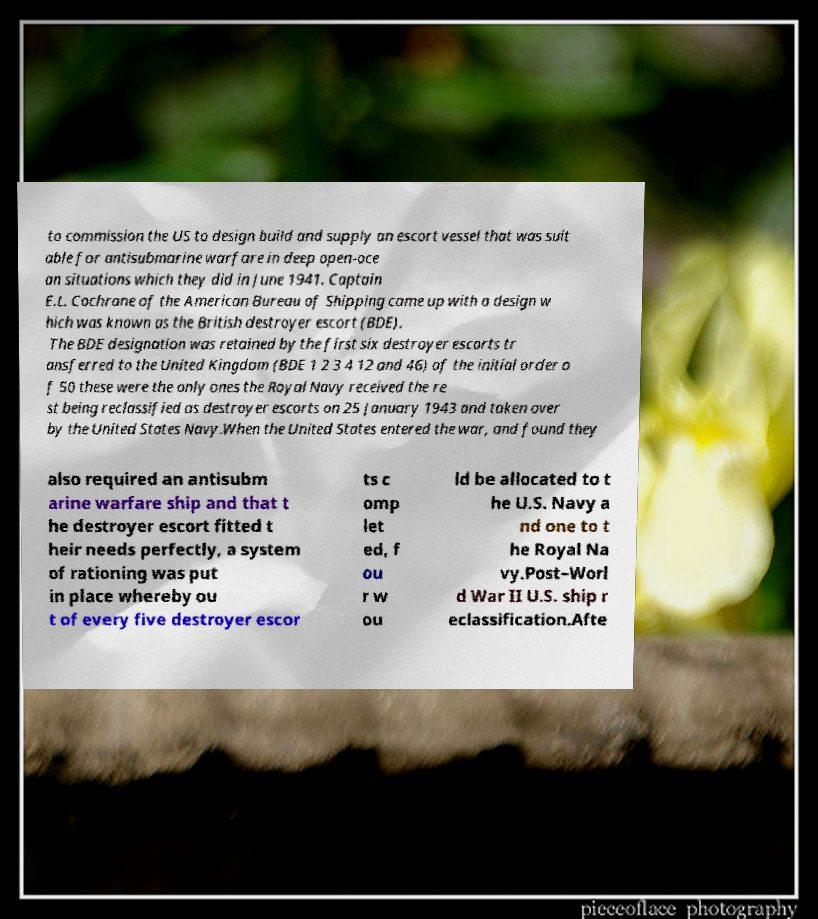I need the written content from this picture converted into text. Can you do that? to commission the US to design build and supply an escort vessel that was suit able for antisubmarine warfare in deep open-oce an situations which they did in June 1941. Captain E.L. Cochrane of the American Bureau of Shipping came up with a design w hich was known as the British destroyer escort (BDE). The BDE designation was retained by the first six destroyer escorts tr ansferred to the United Kingdom (BDE 1 2 3 4 12 and 46) of the initial order o f 50 these were the only ones the Royal Navy received the re st being reclassified as destroyer escorts on 25 January 1943 and taken over by the United States Navy.When the United States entered the war, and found they also required an antisubm arine warfare ship and that t he destroyer escort fitted t heir needs perfectly, a system of rationing was put in place whereby ou t of every five destroyer escor ts c omp let ed, f ou r w ou ld be allocated to t he U.S. Navy a nd one to t he Royal Na vy.Post–Worl d War II U.S. ship r eclassification.Afte 